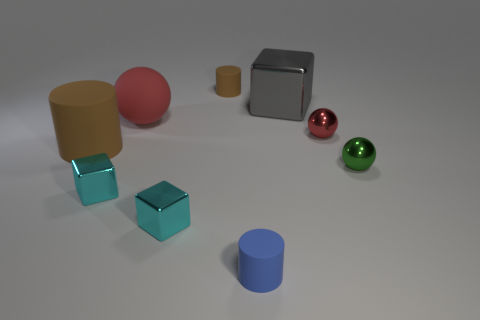Subtract all cyan blocks. How many blocks are left? 1 Add 1 small yellow matte cylinders. How many objects exist? 10 Subtract all blue cylinders. How many cylinders are left? 2 Subtract all blue balls. How many cyan blocks are left? 2 Subtract 1 blocks. How many blocks are left? 2 Subtract all balls. How many objects are left? 6 Subtract all tiny matte things. Subtract all blue rubber cylinders. How many objects are left? 6 Add 7 small green balls. How many small green balls are left? 8 Add 3 yellow matte cylinders. How many yellow matte cylinders exist? 3 Subtract 0 gray cylinders. How many objects are left? 9 